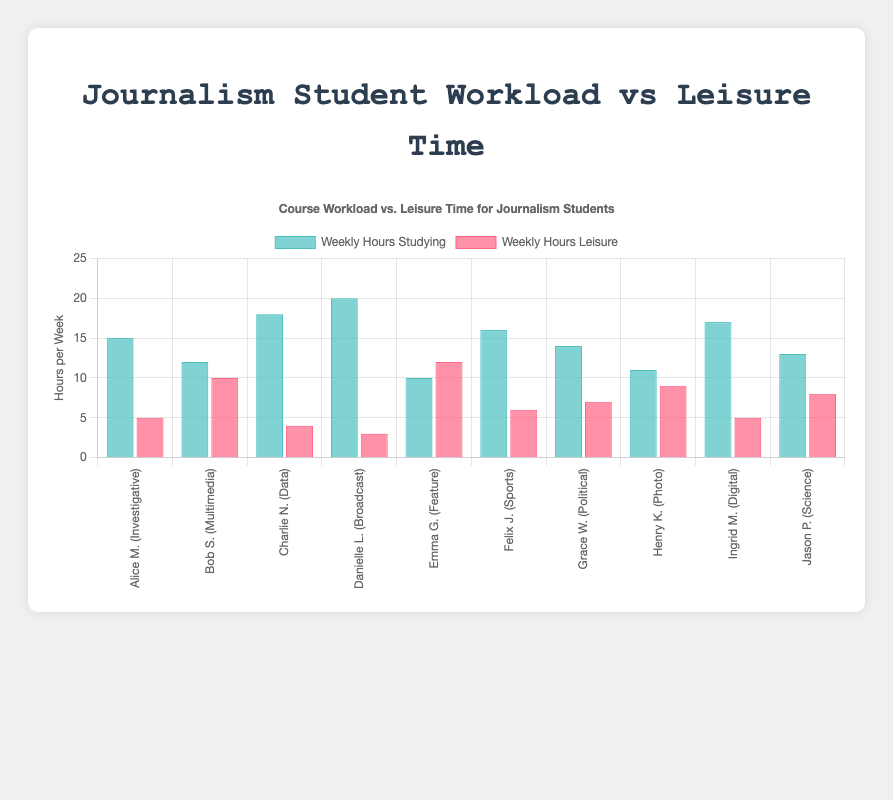Which student spends the most time studying weekly? In the grouped bar chart, find the tallest blue (study hours) bar. In this case, Danielle Lee spends the most time studying, with 20 hours a week.
Answer: Danielle Lee Which student has the most leisure time weekly? Look for the tallest red (leisure hours) bar in the chart. Emma Garza has the most leisure time with 12 hours a week.
Answer: Emma Garza Compare the weekly study hours of Charlie Nguyen and Henry Kim. Who studies more and by how much? Identify the blue bars for Charlie Nguyen and Henry Kim. Charlie studies 18 hours, and Henry studies 11 hours. The difference is 18 - 11 = 7 hours.
Answer: Charlie Nguyen studies 7 hours more Which course has the smallest difference between study and leisure hours? Calculate the absolute difference between study and leisure hours for all students. The smallest difference is for Bob Smith:
Answer: Bob Smith (2 hours difference) What is the average weekly study time across all students? Sum the study hours for all students: 15+12+18+20+10+16+14+11+17+13 = 146 hours, then divide by the number of students, 146 / 10 = 14.6 hours.
Answer: 14.6 hours Identify the course with the least amount of leisure time. Look for the shortest red (leisure hours) bar in the chart. The smallest leisure time is for Danielle Lee with 3 hours a week.
Answer: Broadcast Journalism (3 hours) Compare the weekly leisure time of Ingrid Mueller and Jason Patel. Who has more leisure time and by how much? Find the red bars for Ingrid Mueller and Jason Patel. Ingrid has 5 hours, and Jason has 8 hours. The difference is 8 - 5 = 3 hours.
Answer: Jason Patel has 3 hours more Which students have an equal amount of study and leisure hours? Observing the bars, find any pairs with equal blue and red heights. None of the students have equal study and leisure hours.
Answer: None What's the total amount of leisure time among all students? Sum up the leisure hours for all students: 5+10+4+3+12+6+7+9+5+8 = 69 hours.
Answer: 69 hours Which student has the greatest difference between study and leisure hours? Calculate the absolute difference between study and leisure hours for each student. The greatest difference is for Danielle Lee: 20 - 3 = 17 hours.
Answer: Danielle Lee (17 hours) 